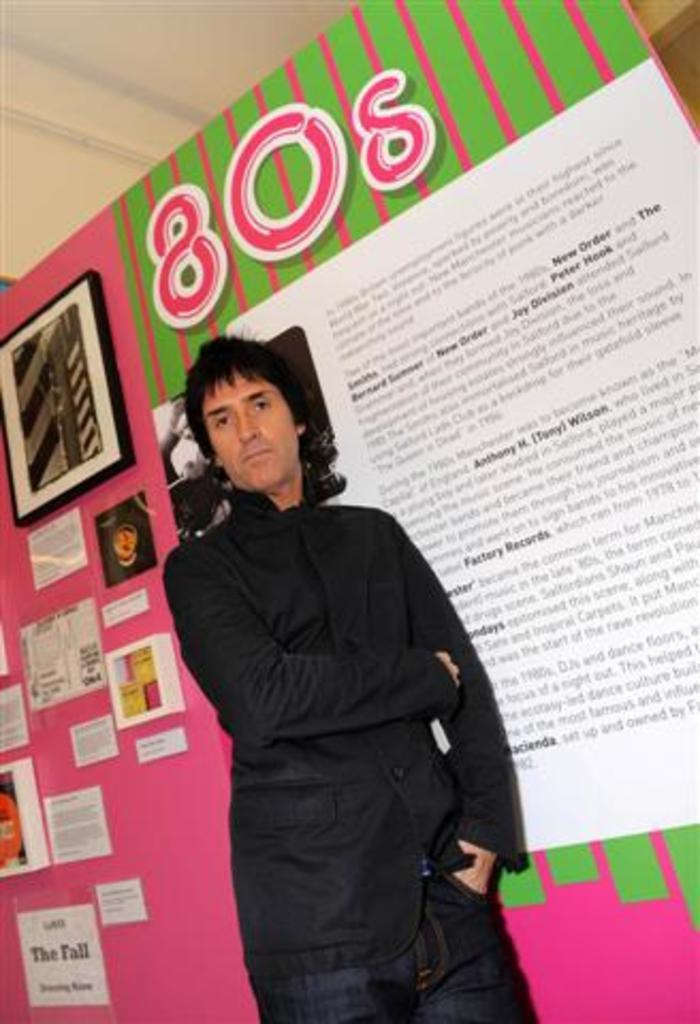Who or what is present in the image? There is a person in the image. What is the person wearing? The person is wearing a black dress. What else can be seen in the image besides the person? There are papers, a board, and a frame in the image. What is the color of the surface the board and frame are attached to? The surface has a pink and green color. How many dimes can be seen on the board in the image? There are no dimes present on the board in the image. Is there a cactus growing near the person in the image? There is no cactus visible in the image. 